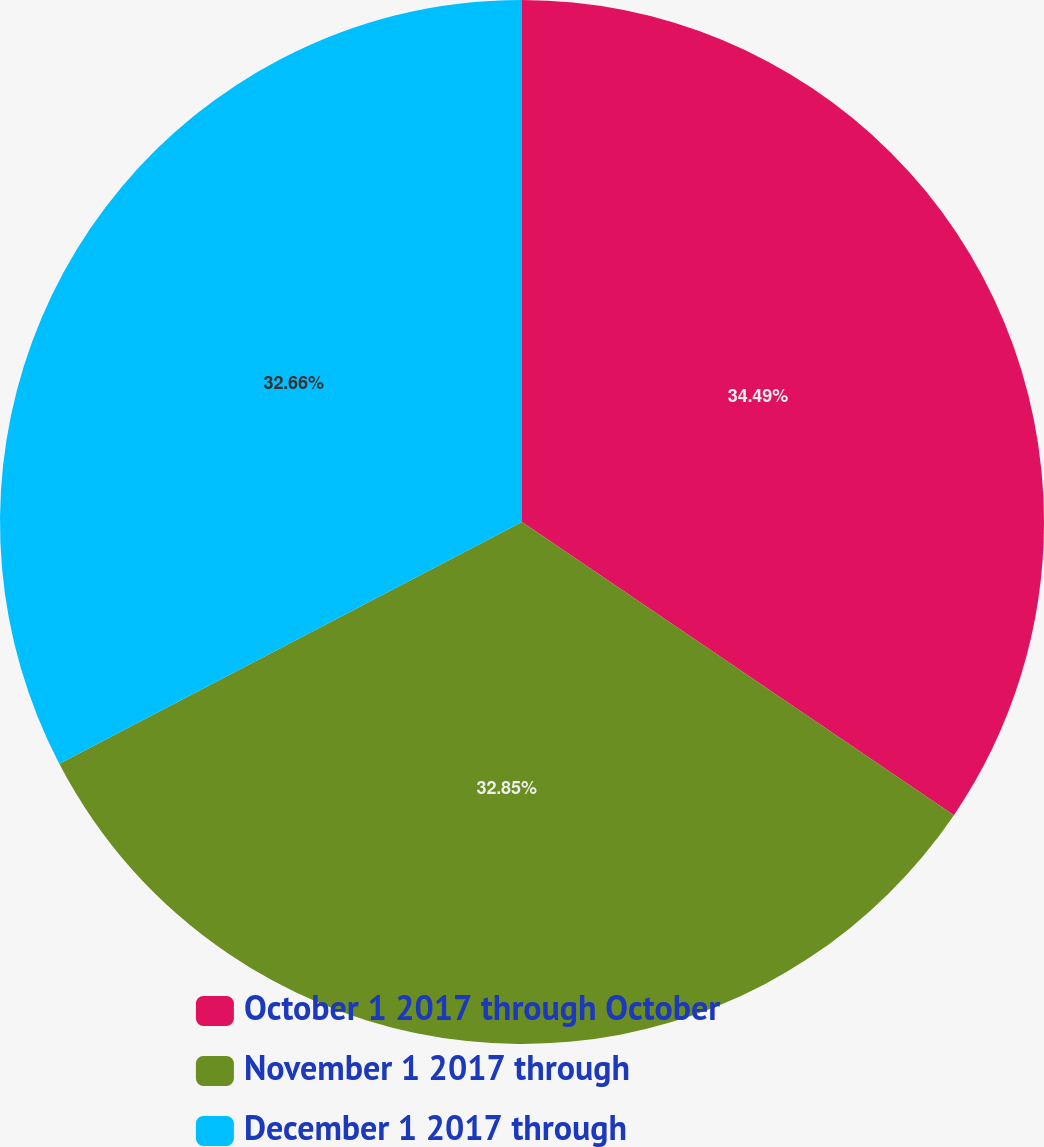<chart> <loc_0><loc_0><loc_500><loc_500><pie_chart><fcel>October 1 2017 through October<fcel>November 1 2017 through<fcel>December 1 2017 through<nl><fcel>34.49%<fcel>32.85%<fcel>32.66%<nl></chart> 